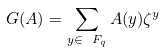Convert formula to latex. <formula><loc_0><loc_0><loc_500><loc_500>G ( A ) = \sum _ { y \in \ F _ { q } } A ( y ) \zeta ^ { y }</formula> 